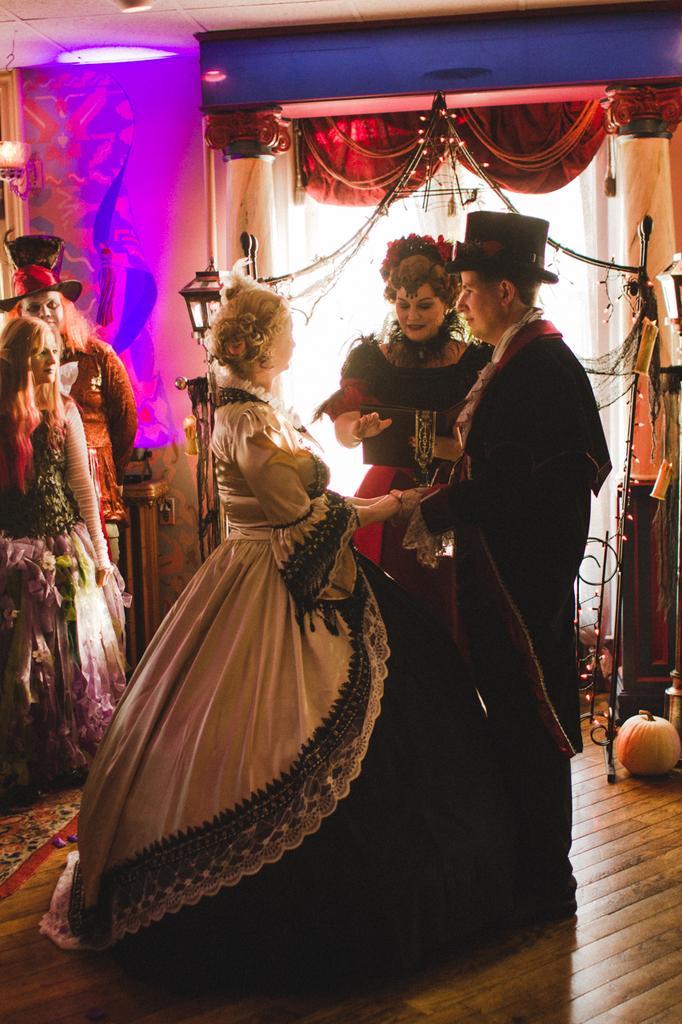Could you give a brief overview of what you see in this image? This image is taken indoors. At the bottom of the image there is a floor. In the background there is a wall with a door and there are a few curtains. There are two pillars. At the top of the image there is a ceiling. On the left side of the image two persons are standing on the mat and there is a table. There is a light. In the middle of the image two women and a man are standing on the floor. On the right side of the image there are a few rope lights and there is a pumpkin on the floor. 